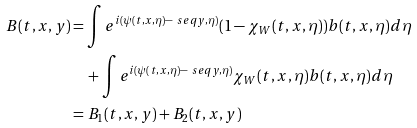Convert formula to latex. <formula><loc_0><loc_0><loc_500><loc_500>B ( t , x , y ) & = \int e ^ { i ( \psi ( t , x , \eta ) - \ s e q { y , \eta } ) } ( 1 - \chi _ { W } ( t , x , \eta ) ) b ( t , x , \eta ) d \eta \\ & \quad + \int e ^ { i ( \psi ( t , x , \eta ) - \ s e q { y , \eta } ) } \chi _ { W } ( t , x , \eta ) b ( t , x , \eta ) d \eta \\ & = B _ { 1 } ( t , x , y ) + B _ { 2 } ( t , x , y )</formula> 